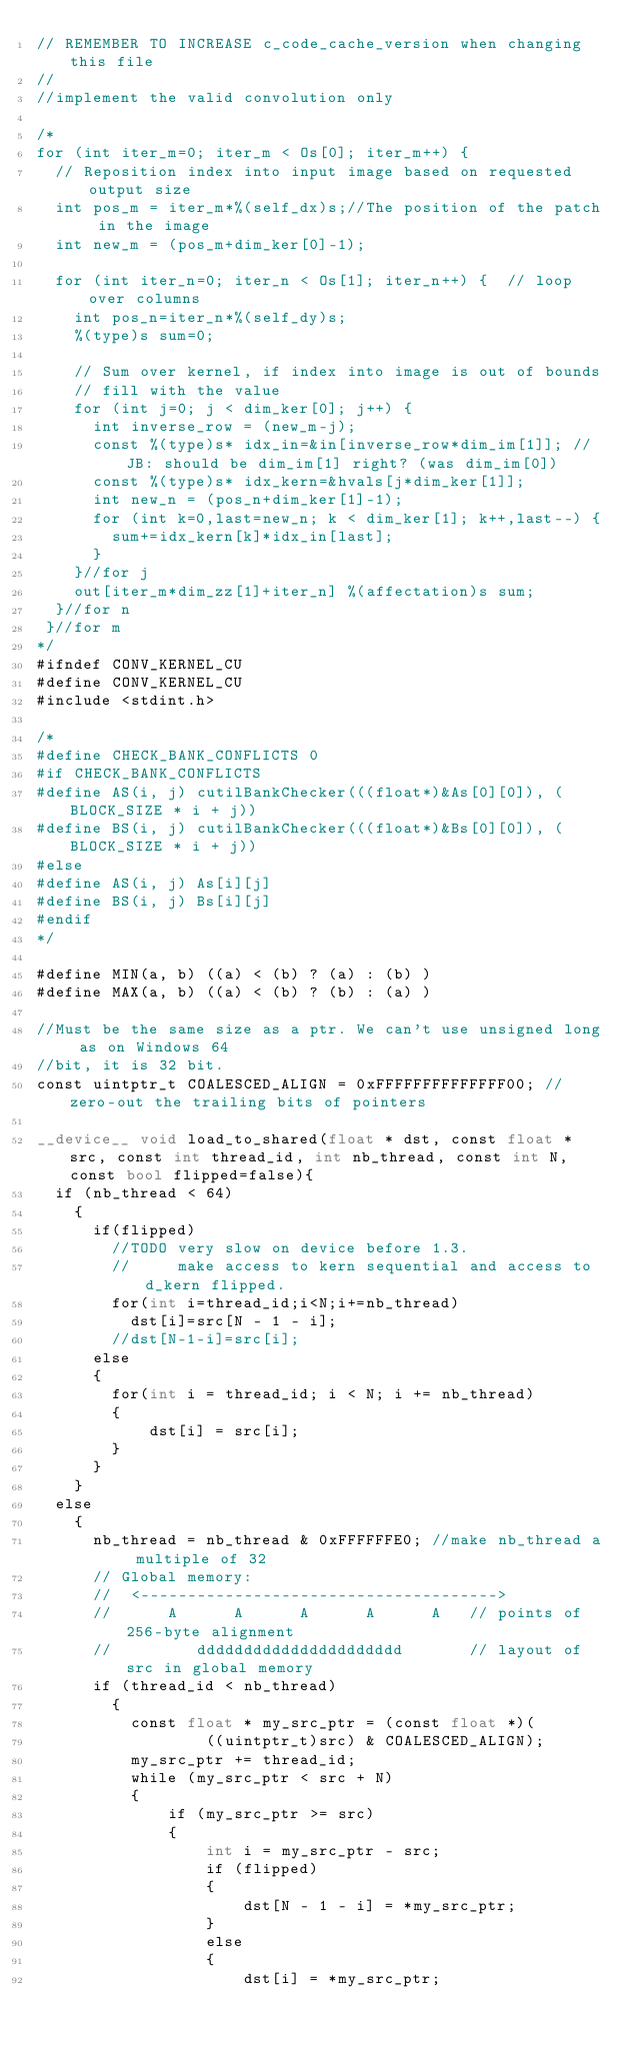<code> <loc_0><loc_0><loc_500><loc_500><_Cuda_>// REMEMBER TO INCREASE c_code_cache_version when changing this file
//
//implement the valid convolution only

/*
for (int iter_m=0; iter_m < Os[0]; iter_m++) {
  // Reposition index into input image based on requested output size
  int pos_m = iter_m*%(self_dx)s;//The position of the patch in the image
  int new_m = (pos_m+dim_ker[0]-1);

  for (int iter_n=0; iter_n < Os[1]; iter_n++) {  // loop over columns
    int pos_n=iter_n*%(self_dy)s;
    %(type)s sum=0;

    // Sum over kernel, if index into image is out of bounds
    // fill with the value
    for (int j=0; j < dim_ker[0]; j++) {
      int inverse_row = (new_m-j);
      const %(type)s* idx_in=&in[inverse_row*dim_im[1]]; //JB: should be dim_im[1] right? (was dim_im[0])
      const %(type)s* idx_kern=&hvals[j*dim_ker[1]];
      int new_n = (pos_n+dim_ker[1]-1);
      for (int k=0,last=new_n; k < dim_ker[1]; k++,last--) {
        sum+=idx_kern[k]*idx_in[last];
      }
    }//for j
    out[iter_m*dim_zz[1]+iter_n] %(affectation)s sum;
  }//for n
 }//for m
*/
#ifndef CONV_KERNEL_CU
#define CONV_KERNEL_CU
#include <stdint.h>

/*
#define CHECK_BANK_CONFLICTS 0
#if CHECK_BANK_CONFLICTS
#define AS(i, j) cutilBankChecker(((float*)&As[0][0]), (BLOCK_SIZE * i + j))
#define BS(i, j) cutilBankChecker(((float*)&Bs[0][0]), (BLOCK_SIZE * i + j))
#else
#define AS(i, j) As[i][j]
#define BS(i, j) Bs[i][j]
#endif
*/

#define MIN(a, b) ((a) < (b) ? (a) : (b) )
#define MAX(a, b) ((a) < (b) ? (b) : (a) )

//Must be the same size as a ptr. We can't use unsigned long as on Windows 64
//bit, it is 32 bit.
const uintptr_t COALESCED_ALIGN = 0xFFFFFFFFFFFFFF00; // zero-out the trailing bits of pointers

__device__ void load_to_shared(float * dst, const float * src, const int thread_id, int nb_thread, const int N, const bool flipped=false){
  if (nb_thread < 64)
    {
      if(flipped)
        //TODO very slow on device before 1.3.
        //     make access to kern sequential and access to d_kern flipped.
        for(int i=thread_id;i<N;i+=nb_thread)
          dst[i]=src[N - 1 - i];
        //dst[N-1-i]=src[i];
      else
      {
        for(int i = thread_id; i < N; i += nb_thread)
        {
            dst[i] = src[i];
        }
      }
    }
  else
    {
      nb_thread = nb_thread & 0xFFFFFFE0; //make nb_thread a multiple of 32
      // Global memory:
      //  <-------------------------------------->
      //      A      A      A      A      A   // points of 256-byte alignment
      //         dddddddddddddddddddddd       // layout of src in global memory
      if (thread_id < nb_thread)
        {
          const float * my_src_ptr = (const float *)(
                  ((uintptr_t)src) & COALESCED_ALIGN);
          my_src_ptr += thread_id;
          while (my_src_ptr < src + N)
          {
              if (my_src_ptr >= src)
              {
                  int i = my_src_ptr - src;
                  if (flipped)
                  {
                      dst[N - 1 - i] = *my_src_ptr;
                  }
                  else
                  {
                      dst[i] = *my_src_ptr;</code> 